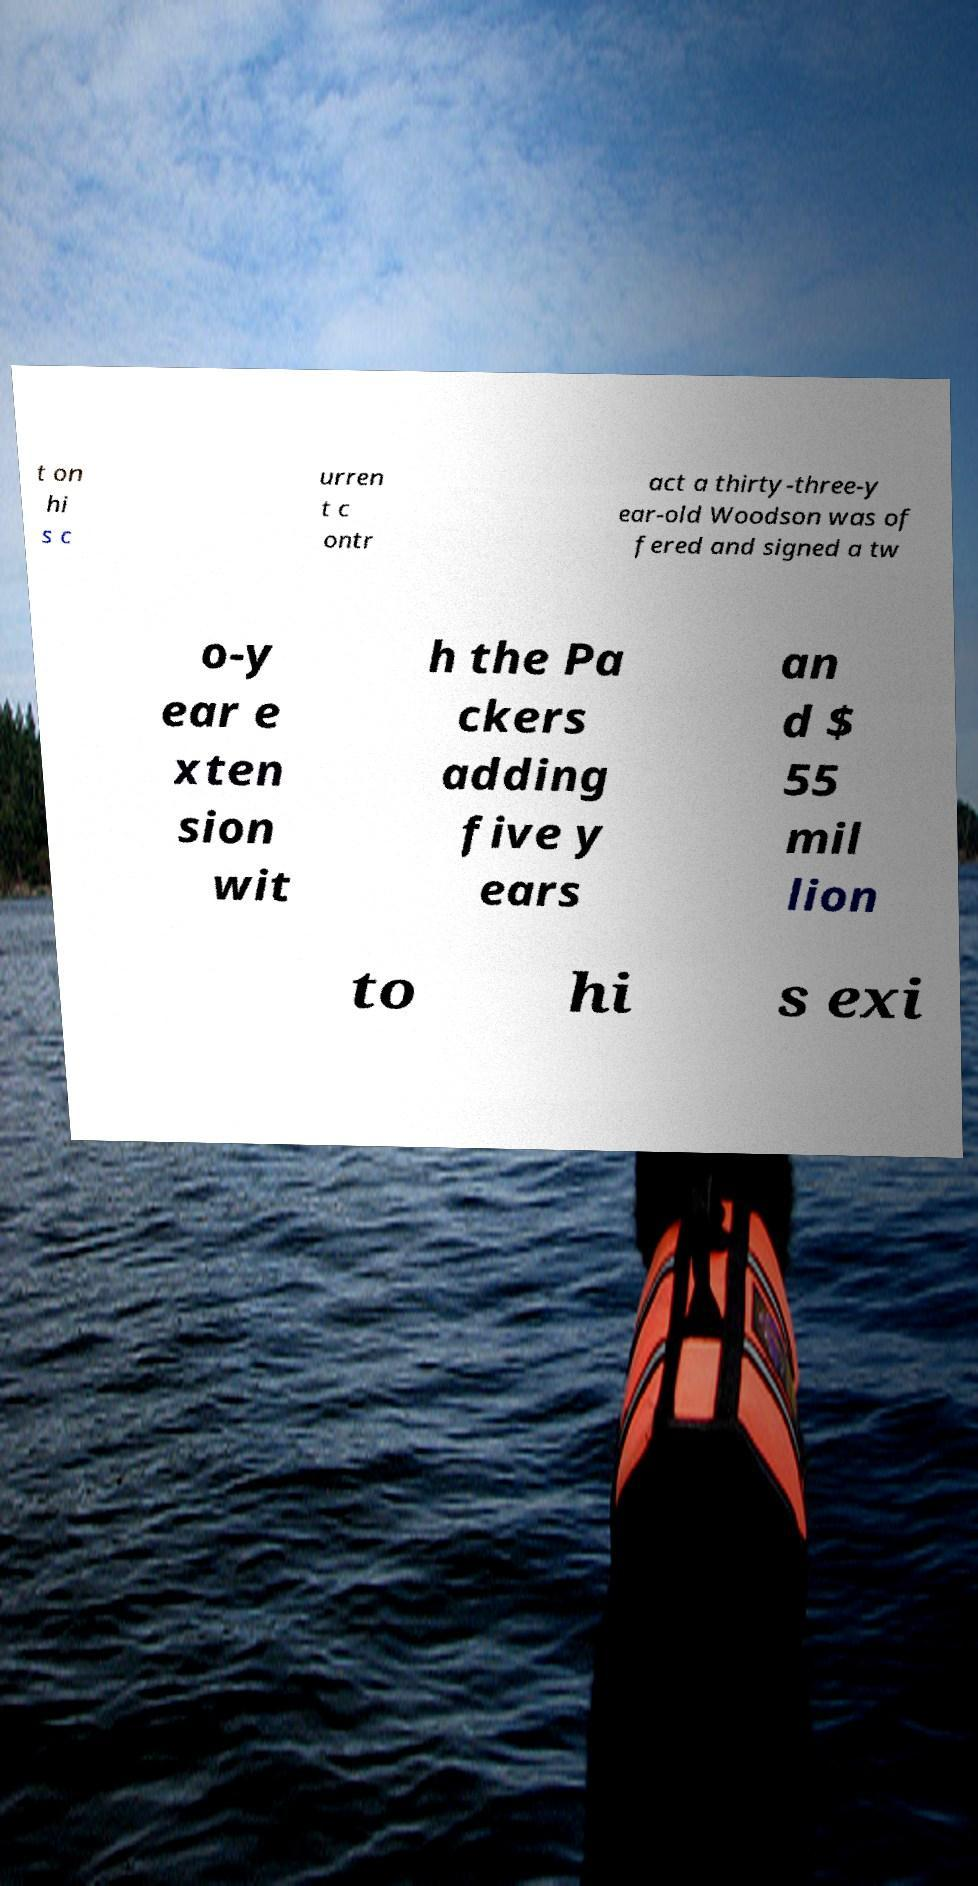Please identify and transcribe the text found in this image. t on hi s c urren t c ontr act a thirty-three-y ear-old Woodson was of fered and signed a tw o-y ear e xten sion wit h the Pa ckers adding five y ears an d $ 55 mil lion to hi s exi 